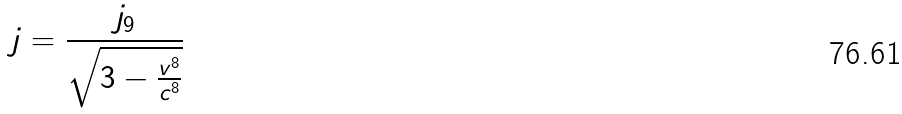<formula> <loc_0><loc_0><loc_500><loc_500>j = \frac { j _ { 9 } } { \sqrt { 3 - \frac { v ^ { 8 } } { c ^ { 8 } } } }</formula> 